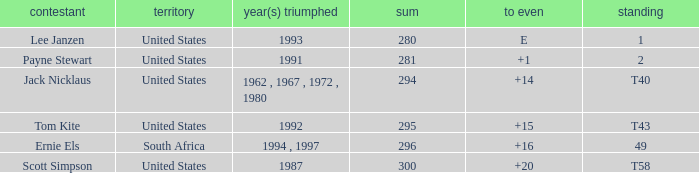What is the Total of the Player with a Finish of 1? 1.0. 